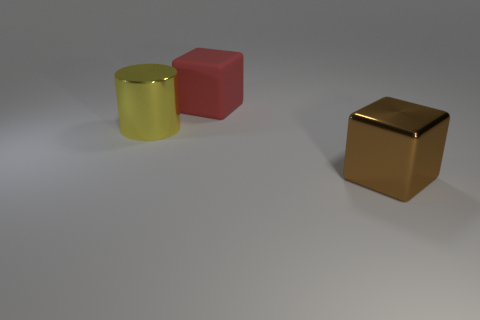Add 2 spheres. How many objects exist? 5 Subtract all cubes. How many objects are left? 1 Subtract 0 gray blocks. How many objects are left? 3 Subtract all brown metal spheres. Subtract all big objects. How many objects are left? 0 Add 2 big rubber things. How many big rubber things are left? 3 Add 1 yellow things. How many yellow things exist? 2 